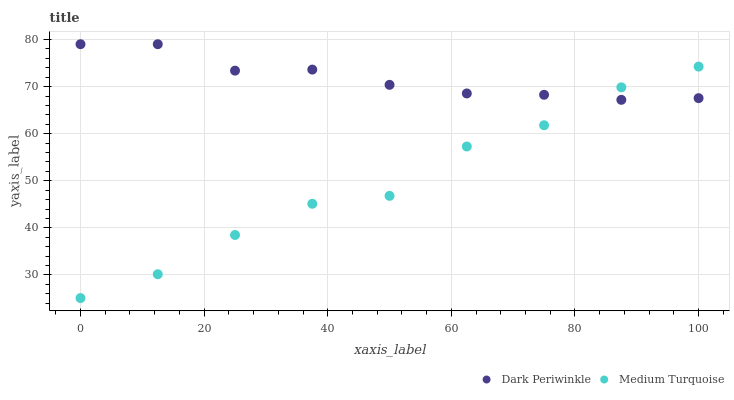Does Medium Turquoise have the minimum area under the curve?
Answer yes or no. Yes. Does Dark Periwinkle have the maximum area under the curve?
Answer yes or no. Yes. Does Medium Turquoise have the maximum area under the curve?
Answer yes or no. No. Is Dark Periwinkle the smoothest?
Answer yes or no. Yes. Is Medium Turquoise the roughest?
Answer yes or no. Yes. Is Medium Turquoise the smoothest?
Answer yes or no. No. Does Medium Turquoise have the lowest value?
Answer yes or no. Yes. Does Dark Periwinkle have the highest value?
Answer yes or no. Yes. Does Medium Turquoise have the highest value?
Answer yes or no. No. Does Dark Periwinkle intersect Medium Turquoise?
Answer yes or no. Yes. Is Dark Periwinkle less than Medium Turquoise?
Answer yes or no. No. Is Dark Periwinkle greater than Medium Turquoise?
Answer yes or no. No. 